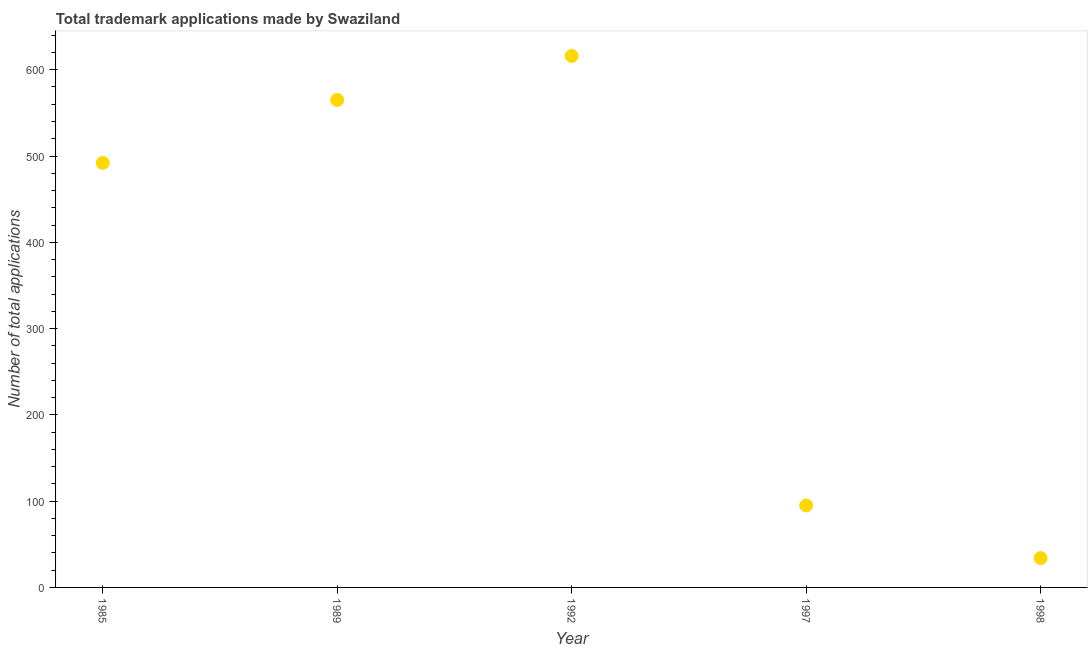What is the number of trademark applications in 1992?
Offer a terse response. 616. Across all years, what is the maximum number of trademark applications?
Provide a succinct answer. 616. Across all years, what is the minimum number of trademark applications?
Provide a succinct answer. 34. In which year was the number of trademark applications maximum?
Offer a terse response. 1992. What is the sum of the number of trademark applications?
Ensure brevity in your answer.  1802. What is the difference between the number of trademark applications in 1985 and 1992?
Your answer should be compact. -124. What is the average number of trademark applications per year?
Your response must be concise. 360.4. What is the median number of trademark applications?
Provide a succinct answer. 492. Do a majority of the years between 1998 and 1992 (inclusive) have number of trademark applications greater than 380 ?
Offer a terse response. No. What is the ratio of the number of trademark applications in 1989 to that in 1998?
Give a very brief answer. 16.62. Is the number of trademark applications in 1989 less than that in 1992?
Provide a short and direct response. Yes. Is the difference between the number of trademark applications in 1985 and 1997 greater than the difference between any two years?
Ensure brevity in your answer.  No. What is the difference between the highest and the lowest number of trademark applications?
Provide a succinct answer. 582. What is the difference between two consecutive major ticks on the Y-axis?
Ensure brevity in your answer.  100. Does the graph contain any zero values?
Make the answer very short. No. Does the graph contain grids?
Offer a terse response. No. What is the title of the graph?
Provide a short and direct response. Total trademark applications made by Swaziland. What is the label or title of the X-axis?
Give a very brief answer. Year. What is the label or title of the Y-axis?
Provide a short and direct response. Number of total applications. What is the Number of total applications in 1985?
Ensure brevity in your answer.  492. What is the Number of total applications in 1989?
Keep it short and to the point. 565. What is the Number of total applications in 1992?
Your response must be concise. 616. What is the Number of total applications in 1997?
Provide a short and direct response. 95. What is the Number of total applications in 1998?
Give a very brief answer. 34. What is the difference between the Number of total applications in 1985 and 1989?
Give a very brief answer. -73. What is the difference between the Number of total applications in 1985 and 1992?
Provide a succinct answer. -124. What is the difference between the Number of total applications in 1985 and 1997?
Keep it short and to the point. 397. What is the difference between the Number of total applications in 1985 and 1998?
Offer a terse response. 458. What is the difference between the Number of total applications in 1989 and 1992?
Provide a short and direct response. -51. What is the difference between the Number of total applications in 1989 and 1997?
Your answer should be compact. 470. What is the difference between the Number of total applications in 1989 and 1998?
Make the answer very short. 531. What is the difference between the Number of total applications in 1992 and 1997?
Keep it short and to the point. 521. What is the difference between the Number of total applications in 1992 and 1998?
Make the answer very short. 582. What is the ratio of the Number of total applications in 1985 to that in 1989?
Ensure brevity in your answer.  0.87. What is the ratio of the Number of total applications in 1985 to that in 1992?
Make the answer very short. 0.8. What is the ratio of the Number of total applications in 1985 to that in 1997?
Give a very brief answer. 5.18. What is the ratio of the Number of total applications in 1985 to that in 1998?
Make the answer very short. 14.47. What is the ratio of the Number of total applications in 1989 to that in 1992?
Provide a short and direct response. 0.92. What is the ratio of the Number of total applications in 1989 to that in 1997?
Provide a succinct answer. 5.95. What is the ratio of the Number of total applications in 1989 to that in 1998?
Provide a short and direct response. 16.62. What is the ratio of the Number of total applications in 1992 to that in 1997?
Keep it short and to the point. 6.48. What is the ratio of the Number of total applications in 1992 to that in 1998?
Your answer should be very brief. 18.12. What is the ratio of the Number of total applications in 1997 to that in 1998?
Your answer should be very brief. 2.79. 